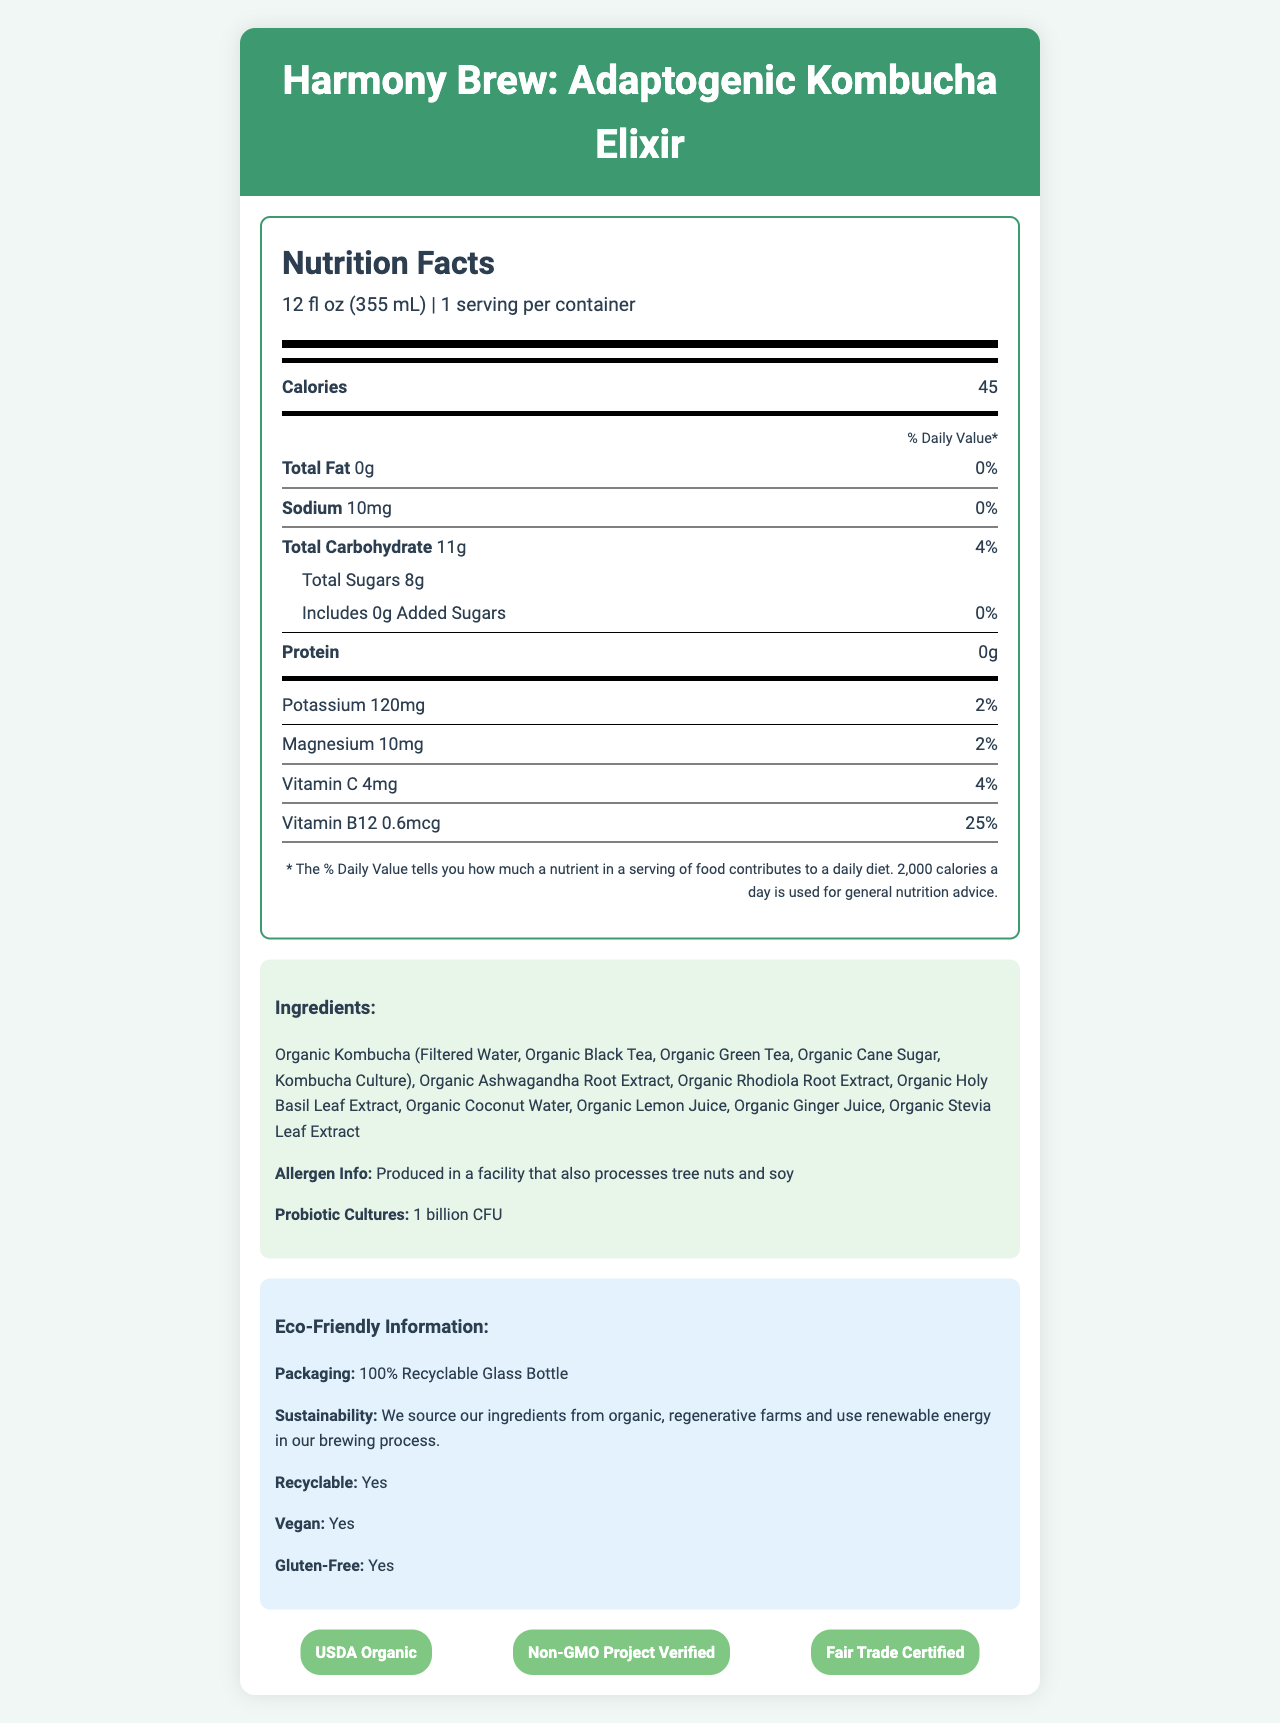how many calories are in one serving of Harmony Brew? One serving of Harmony Brew contains 45 calories, as shown in the "Calories" section of the nutrition label.
Answer: 45 how much total carbohydrate is there per serving? The total carbohydrate per serving is indicated as 11g on the nutrition label.
Answer: 11g what is the percentage of daily value for Vitamin B12 in Harmony Brew? The daily value for Vitamin B12 listed on the nutrition label is 25%.
Answer: 25% how much potassium is in a serving? The nutrition label states that there is 120mg of potassium in one serving.
Answer: 120mg are there any added sugars in Harmony Brew? The nutrition label notes that there are 0g of added sugars in Harmony Brew.
Answer: No which ingredient is used as a natural sweetener? The ingredients list includes "Organic Stevia Leaf Extract" as the natural sweetener.
Answer: Organic Stevia Leaf Extract Harmony Brew is certified by which organizations? A. USDA Organic B. Non-GMO Project Verified C. Fair Trade Certified D. All of the above Harmony Brew is certified by USDA Organic, Non-GMO Project Verified, and Fair Trade Certified, as shown in the certifications section.
Answer: D what is the serving size for Harmony Brew? A. 8 fl oz B. 12 fl oz C. 16 fl oz D. 20 fl oz The serving size for Harmony Brew is stated as 12 fl oz (355 mL).
Answer: B does Harmony Brew contain any allergens? Harmony Brew is produced in a facility that also processes tree nuts and soy, as noted in the allergen information.
Answer: Yes is the packaging of Harmony Brew eco-friendly? The document states that Harmony Brew is packaged in 100% recyclable glass bottles.
Answer: Yes describe the main idea of the document. The main idea of the document is to inform the reader about the nutritional content, ingredients, and eco-friendly aspects of Harmony Brew kombucha drink, along with its certifications and health benefits.
Answer: The document provides detailed nutrition facts, ingredients, and certifications for Harmony Brew, a kombucha drink infused with adaptogenic herbs and natural electrolytes. It highlights its eco-friendly packaging, probiotic cultures, and various functional benefits. how is Harmony Brew beneficial for stress? The functional benefits section mentions that the drink supports stress response.
Answer: Supports Stress Response does Harmony Brew promote hydration? The functional benefits section lists "Enhances Hydration" as one of the benefits.
Answer: Yes who provides the ingredients for Harmony Brew? The document states that ingredients are sourced from organic, regenerative farms, but does not provide specific provider names.
Answer: Not enough information how many probiotic cultures are in Harmony Brew? The document specifies that Harmony Brew contains 1 billion CFU of probiotic cultures.
Answer: 1 billion CFU does Harmony Brew contain gluten? The document indicates that Harmony Brew is gluten-free.
Answer: No is Harmony Brew vegan-friendly? The document notes that Harmony Brew is vegan.
Answer: Yes what are the functional benefits of Harmony Brew? The functional benefits listed in the document are Supports Stress Response, Promotes Mental Clarity, Enhances Hydration, and Boosts Immune System.
Answer: Supports Stress Response, Promotes Mental Clarity, Enhances Hydration, Boosts Immune System 